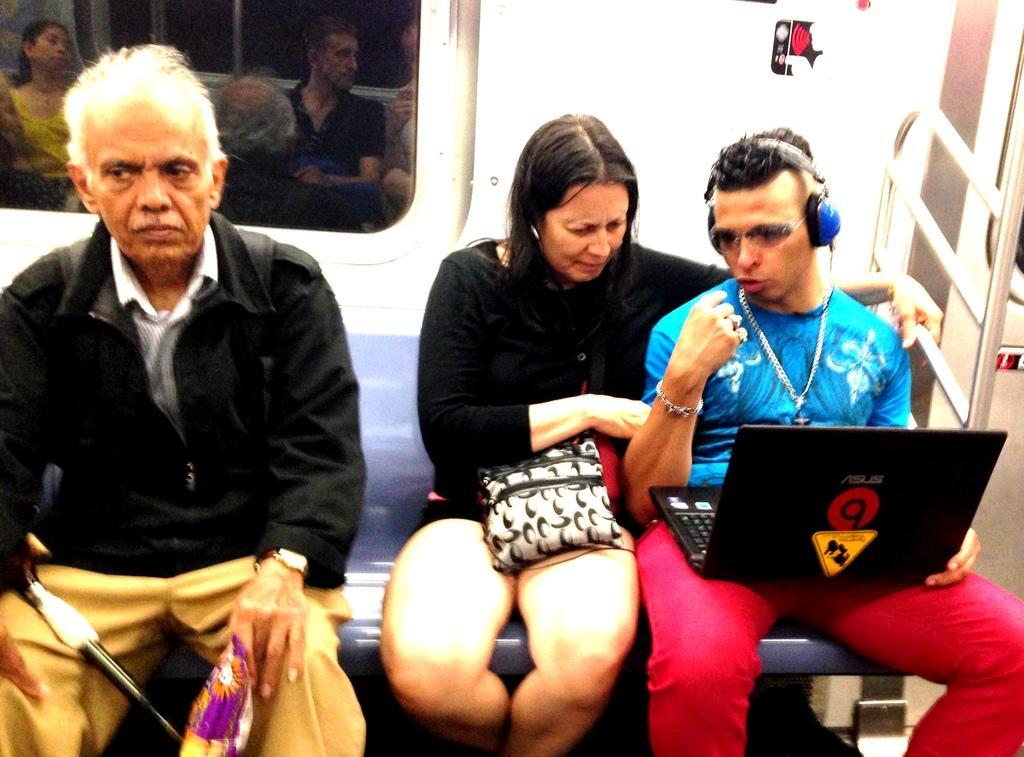In one or two sentences, can you explain what this image depicts? In this image we can see this person wearing a black jacket, this woman wearing a black dress and this person wearing blue T-shirt, headsets is holding a laptop and are sitting on the seat. In the background, we can see the glass window through which we can see the reflection of people sitting on the seat. 